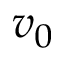<formula> <loc_0><loc_0><loc_500><loc_500>v _ { 0 }</formula> 